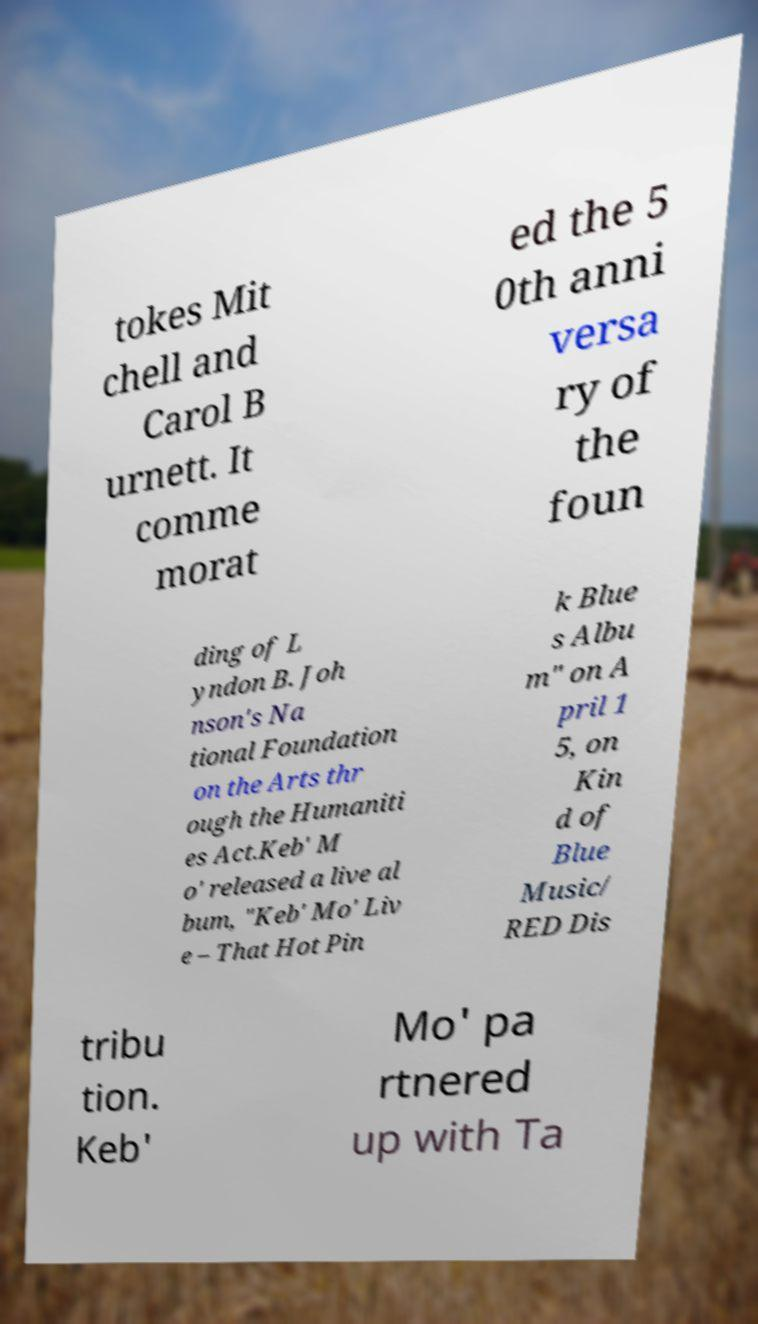Please read and relay the text visible in this image. What does it say? tokes Mit chell and Carol B urnett. It comme morat ed the 5 0th anni versa ry of the foun ding of L yndon B. Joh nson's Na tional Foundation on the Arts thr ough the Humaniti es Act.Keb' M o' released a live al bum, "Keb' Mo' Liv e – That Hot Pin k Blue s Albu m" on A pril 1 5, on Kin d of Blue Music/ RED Dis tribu tion. Keb' Mo' pa rtnered up with Ta 